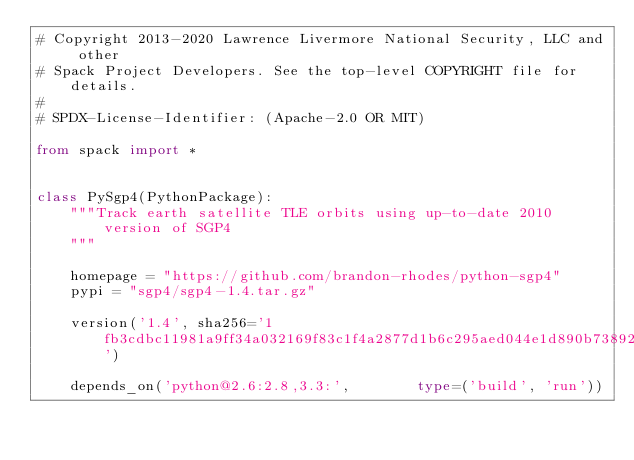<code> <loc_0><loc_0><loc_500><loc_500><_Python_># Copyright 2013-2020 Lawrence Livermore National Security, LLC and other
# Spack Project Developers. See the top-level COPYRIGHT file for details.
#
# SPDX-License-Identifier: (Apache-2.0 OR MIT)

from spack import *


class PySgp4(PythonPackage):
    """Track earth satellite TLE orbits using up-to-date 2010 version of SGP4
    """

    homepage = "https://github.com/brandon-rhodes/python-sgp4"
    pypi = "sgp4/sgp4-1.4.tar.gz"

    version('1.4', sha256='1fb3cdbc11981a9ff34a032169f83c1f4a2877d1b6c295aed044e1d890b73892')

    depends_on('python@2.6:2.8,3.3:',        type=('build', 'run'))
</code> 